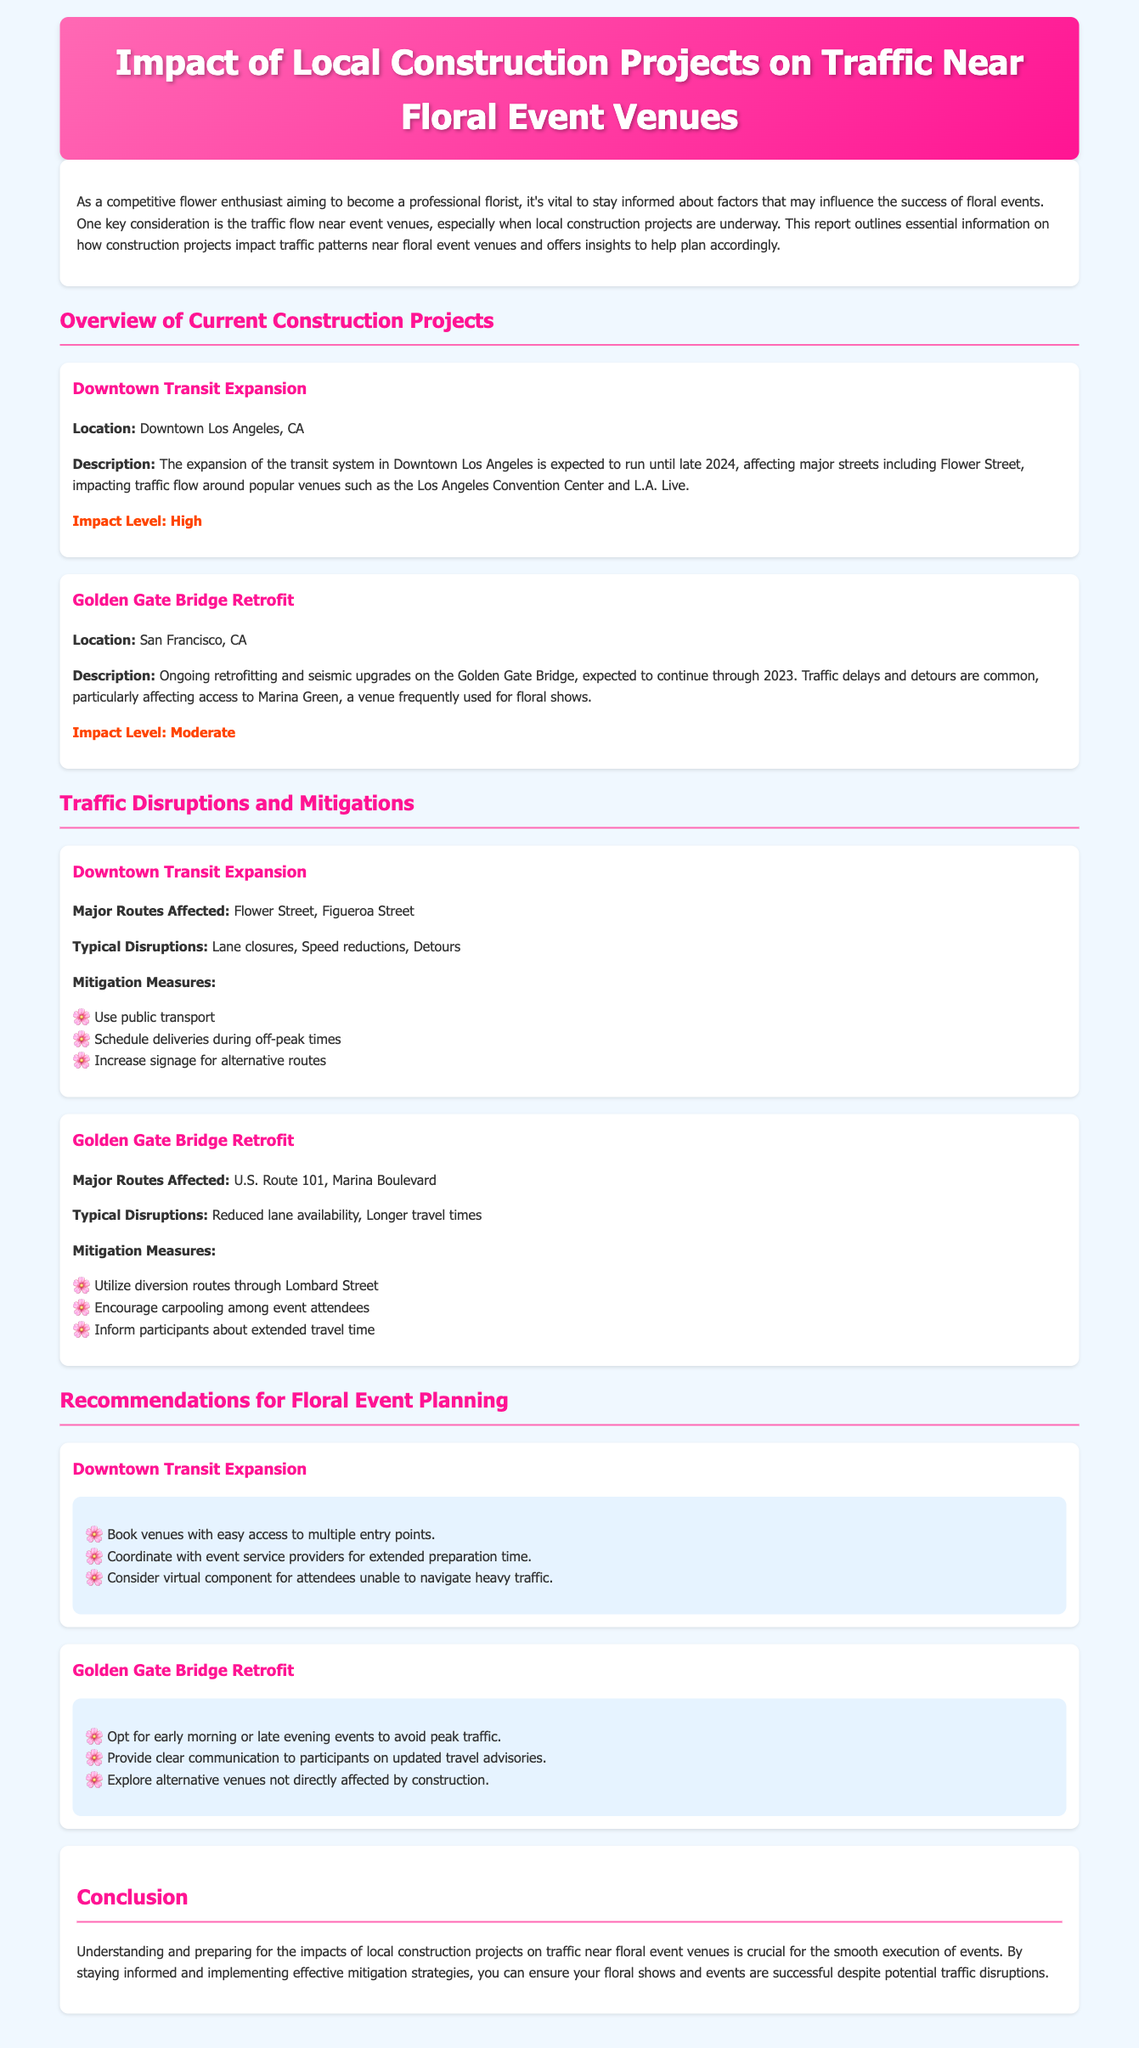What is the title of the report? The title of the report is stated at the top of the document, summarizing the focus on traffic and floral event venues.
Answer: Impact of Local Construction Projects on Traffic Near Floral Event Venues How long is the Downtown Transit Expansion project expected to run? The document provides a specific end date for this construction project, indicating its duration.
Answer: Until late 2024 What is the impact level of the Golden Gate Bridge Retrofit? The impact level for this project is mentioned in the section detailing its description, providing insight into its traffic effects.
Answer: Moderate What major route is affected by the Downtown Transit Expansion? This question seeks to identify a primary roadway impacted by the mentioned construction project, which is explicitly listed in the document.
Answer: Flower Street What is one mitigation measure recommended for the Golden Gate Bridge Retrofit? The report lists several mitigation measures for this project; one example can be directly found in the respective section.
Answer: Utilize diversion routes through Lombard Street What type of events does the report recommend scheduling for the Golden Gate Bridge Retrofit? The report highlights a strategic suggestion regarding the timing of events to minimize traffic issues during this construction period.
Answer: Early morning or late evening events What is one recommendation for planning events near the Downtown Transit Expansion? The document offers various recommendations for event planning in relation to the ongoing construction, reflecting the challenges posed by traffic disruptions.
Answer: Book venues with easy access to multiple entry points What is the location of the Downtown Transit Expansion project? The report specifies the city and area affected by this construction project, which is mentioned under the project description.
Answer: Downtown Los Angeles, CA 